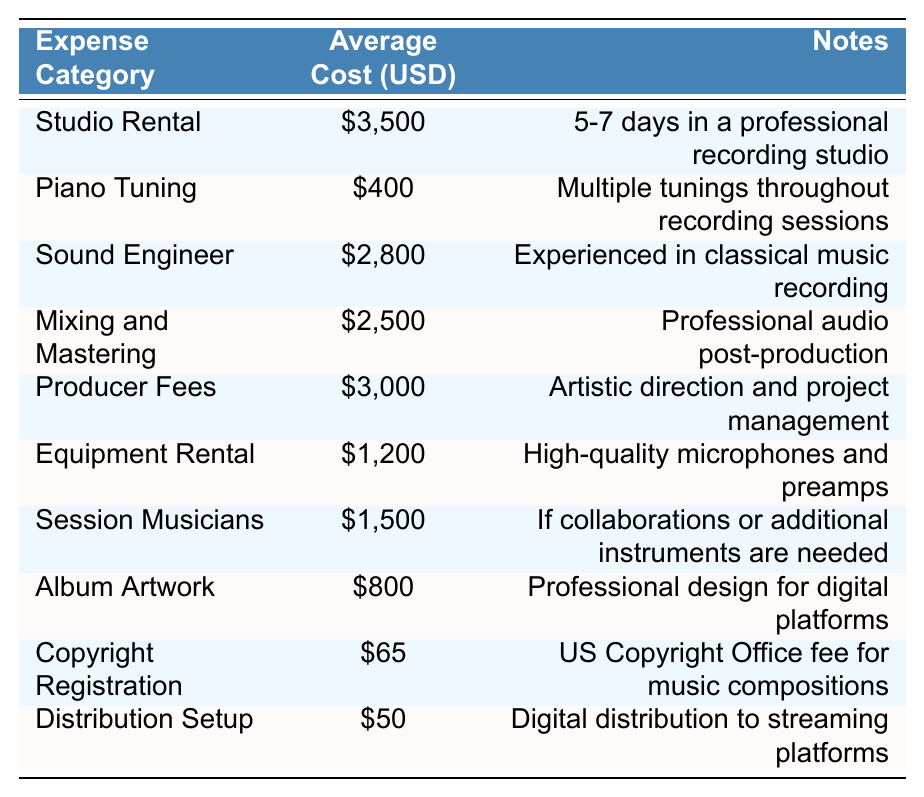What is the average cost of studio rental? The table lists the average cost of studio rental as $3,500.
Answer: $3,500 How much does it cost for piano tuning on average? According to the table, the average cost for piano tuning is $400.
Answer: $400 What is the total average cost of mixing and mastering plus producer fees? The average cost for mixing and mastering is $2,500, and for producer fees, it is $3,000. Adding these gives $2,500 + $3,000 = $5,500.
Answer: $5,500 Is the equipment rental cost higher than the session musicians cost? The table shows that equipment rental costs $1,200, while session musicians cost $1,500. $1,200 is not higher than $1,500, so the answer is no.
Answer: No What is the average cost of copyright registration compared to the distribution setup? The copyright registration costs $65 and the distribution setup costs $50. $65 is greater than $50, meaning it costs more to register copyright than to set up distribution.
Answer: Yes If you sum the average costs of all expense categories, what is the total? The total can be calculated by adding all the average costs: $3,500 + $400 + $2,800 + $2,500 + $3,000 + $1,200 + $1,500 + $800 + $65 + $50 = $15,815.
Answer: $15,815 What percentage of the total cost is represented by studio rental? The studio rental cost is $3,500. To find its percentage of the total $15,815, calculate ($3,500 / $15,815) * 100 = approximately 22.1%.
Answer: 22.1% Which cost is the lowest in the table? The table lists copyright registration as the lowest cost at $65.
Answer: $65 What is the combined cost of album artwork and distribution setup? The average cost of album artwork is $800, and distribution setup is $50. Adding them gives $800 + $50 = $850.
Answer: $850 Which expense category has the highest average cost? Studio rental has the highest average cost at $3,500, as indicated in the table.
Answer: Studio Rental 